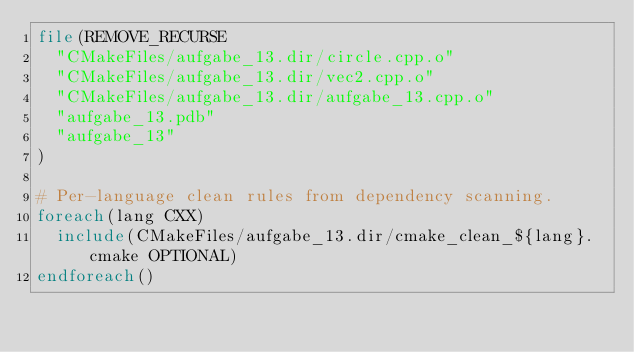Convert code to text. <code><loc_0><loc_0><loc_500><loc_500><_CMake_>file(REMOVE_RECURSE
  "CMakeFiles/aufgabe_13.dir/circle.cpp.o"
  "CMakeFiles/aufgabe_13.dir/vec2.cpp.o"
  "CMakeFiles/aufgabe_13.dir/aufgabe_13.cpp.o"
  "aufgabe_13.pdb"
  "aufgabe_13"
)

# Per-language clean rules from dependency scanning.
foreach(lang CXX)
  include(CMakeFiles/aufgabe_13.dir/cmake_clean_${lang}.cmake OPTIONAL)
endforeach()
</code> 